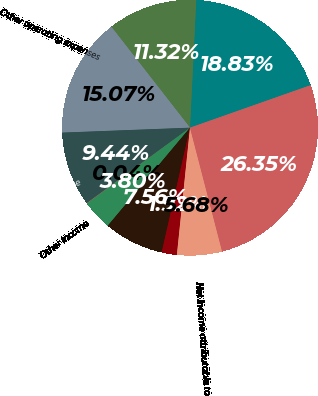Convert chart. <chart><loc_0><loc_0><loc_500><loc_500><pie_chart><fcel>Electric operating revenues<fcel>Fuel and purchased power costs<fcel>Other operating expenses<fcel>Operating income<fcel>Other income<fcel>Interest expense - net of<fcel>Net income<fcel>Less Net income attributable<fcel>Net income attributable to<fcel>Total assets<nl><fcel>18.84%<fcel>11.32%<fcel>15.08%<fcel>9.44%<fcel>0.04%<fcel>3.8%<fcel>7.56%<fcel>1.92%<fcel>5.68%<fcel>26.36%<nl></chart> 